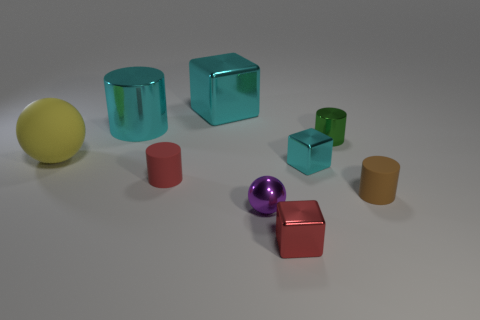How many objects are there in total, and can you categorize them by their shapes? In total, there are nine objects in the image. They can be categorized by their shapes as follows: two cylinders (one cyan, one mustard), two spheres (one yellow, one purple), and five cubes (one red and shiny, one transparent blue, one smaller green, and two non-reflective with an orange and a brown color). 